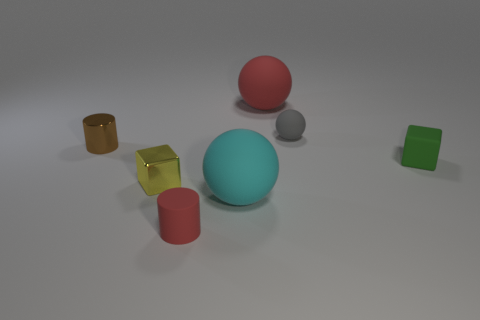What material is the ball that is the same color as the matte cylinder?
Your response must be concise. Rubber. What color is the large matte sphere behind the cube that is to the right of the large cyan sphere?
Keep it short and to the point. Red. Are there any yellow cubes that have the same material as the large red sphere?
Your response must be concise. No. What material is the ball behind the tiny matte sphere behind the small brown metal cylinder made of?
Provide a short and direct response. Rubber. How many large cyan matte objects are the same shape as the tiny yellow metal thing?
Your answer should be compact. 0. There is a gray matte object; what shape is it?
Your answer should be compact. Sphere. Is the number of small green objects less than the number of large gray cylinders?
Your response must be concise. No. Is there anything else that is the same size as the cyan ball?
Offer a terse response. Yes. There is another thing that is the same shape as the small yellow metallic object; what is it made of?
Your response must be concise. Rubber. Are there more green matte cylinders than large objects?
Make the answer very short. No. 